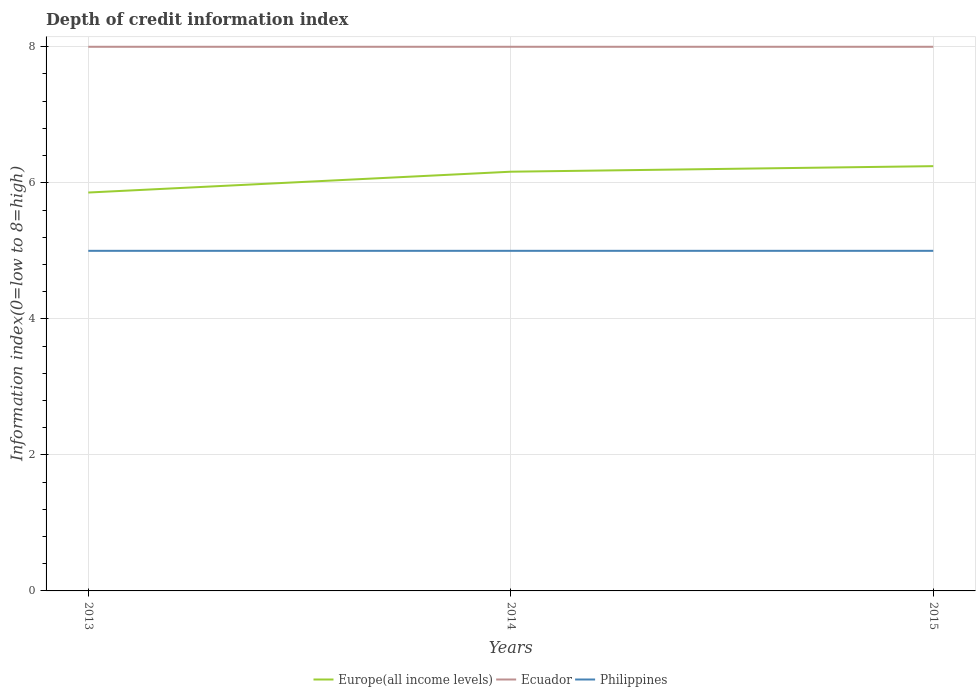How many different coloured lines are there?
Keep it short and to the point. 3. Does the line corresponding to Ecuador intersect with the line corresponding to Philippines?
Offer a terse response. No. Is the number of lines equal to the number of legend labels?
Offer a very short reply. Yes. Across all years, what is the maximum information index in Europe(all income levels)?
Offer a terse response. 5.86. In which year was the information index in Philippines maximum?
Keep it short and to the point. 2013. What is the total information index in Philippines in the graph?
Offer a terse response. 0. How many lines are there?
Give a very brief answer. 3. How many years are there in the graph?
Offer a very short reply. 3. Are the values on the major ticks of Y-axis written in scientific E-notation?
Provide a short and direct response. No. Does the graph contain grids?
Ensure brevity in your answer.  Yes. Where does the legend appear in the graph?
Ensure brevity in your answer.  Bottom center. How are the legend labels stacked?
Keep it short and to the point. Horizontal. What is the title of the graph?
Your response must be concise. Depth of credit information index. What is the label or title of the Y-axis?
Provide a succinct answer. Information index(0=low to 8=high). What is the Information index(0=low to 8=high) in Europe(all income levels) in 2013?
Offer a very short reply. 5.86. What is the Information index(0=low to 8=high) in Europe(all income levels) in 2014?
Provide a succinct answer. 6.16. What is the Information index(0=low to 8=high) of Ecuador in 2014?
Offer a terse response. 8. What is the Information index(0=low to 8=high) in Europe(all income levels) in 2015?
Keep it short and to the point. 6.24. What is the Information index(0=low to 8=high) of Ecuador in 2015?
Your answer should be compact. 8. Across all years, what is the maximum Information index(0=low to 8=high) of Europe(all income levels)?
Provide a succinct answer. 6.24. Across all years, what is the maximum Information index(0=low to 8=high) of Philippines?
Make the answer very short. 5. Across all years, what is the minimum Information index(0=low to 8=high) of Europe(all income levels)?
Provide a succinct answer. 5.86. Across all years, what is the minimum Information index(0=low to 8=high) of Ecuador?
Keep it short and to the point. 8. What is the total Information index(0=low to 8=high) of Europe(all income levels) in the graph?
Keep it short and to the point. 18.27. What is the total Information index(0=low to 8=high) in Ecuador in the graph?
Your response must be concise. 24. What is the difference between the Information index(0=low to 8=high) in Europe(all income levels) in 2013 and that in 2014?
Offer a terse response. -0.31. What is the difference between the Information index(0=low to 8=high) in Philippines in 2013 and that in 2014?
Give a very brief answer. 0. What is the difference between the Information index(0=low to 8=high) in Europe(all income levels) in 2013 and that in 2015?
Ensure brevity in your answer.  -0.39. What is the difference between the Information index(0=low to 8=high) in Europe(all income levels) in 2014 and that in 2015?
Offer a very short reply. -0.08. What is the difference between the Information index(0=low to 8=high) of Europe(all income levels) in 2013 and the Information index(0=low to 8=high) of Ecuador in 2014?
Offer a very short reply. -2.14. What is the difference between the Information index(0=low to 8=high) in Ecuador in 2013 and the Information index(0=low to 8=high) in Philippines in 2014?
Ensure brevity in your answer.  3. What is the difference between the Information index(0=low to 8=high) in Europe(all income levels) in 2013 and the Information index(0=low to 8=high) in Ecuador in 2015?
Your answer should be very brief. -2.14. What is the difference between the Information index(0=low to 8=high) in Europe(all income levels) in 2013 and the Information index(0=low to 8=high) in Philippines in 2015?
Your answer should be very brief. 0.86. What is the difference between the Information index(0=low to 8=high) of Europe(all income levels) in 2014 and the Information index(0=low to 8=high) of Ecuador in 2015?
Ensure brevity in your answer.  -1.84. What is the difference between the Information index(0=low to 8=high) of Europe(all income levels) in 2014 and the Information index(0=low to 8=high) of Philippines in 2015?
Provide a succinct answer. 1.16. What is the difference between the Information index(0=low to 8=high) in Ecuador in 2014 and the Information index(0=low to 8=high) in Philippines in 2015?
Keep it short and to the point. 3. What is the average Information index(0=low to 8=high) in Europe(all income levels) per year?
Provide a succinct answer. 6.09. In the year 2013, what is the difference between the Information index(0=low to 8=high) of Europe(all income levels) and Information index(0=low to 8=high) of Ecuador?
Offer a very short reply. -2.14. In the year 2013, what is the difference between the Information index(0=low to 8=high) of Europe(all income levels) and Information index(0=low to 8=high) of Philippines?
Make the answer very short. 0.86. In the year 2014, what is the difference between the Information index(0=low to 8=high) in Europe(all income levels) and Information index(0=low to 8=high) in Ecuador?
Provide a short and direct response. -1.84. In the year 2014, what is the difference between the Information index(0=low to 8=high) of Europe(all income levels) and Information index(0=low to 8=high) of Philippines?
Ensure brevity in your answer.  1.16. In the year 2014, what is the difference between the Information index(0=low to 8=high) of Ecuador and Information index(0=low to 8=high) of Philippines?
Offer a terse response. 3. In the year 2015, what is the difference between the Information index(0=low to 8=high) in Europe(all income levels) and Information index(0=low to 8=high) in Ecuador?
Your answer should be compact. -1.76. In the year 2015, what is the difference between the Information index(0=low to 8=high) in Europe(all income levels) and Information index(0=low to 8=high) in Philippines?
Your answer should be very brief. 1.24. What is the ratio of the Information index(0=low to 8=high) in Europe(all income levels) in 2013 to that in 2014?
Keep it short and to the point. 0.95. What is the ratio of the Information index(0=low to 8=high) in Europe(all income levels) in 2013 to that in 2015?
Make the answer very short. 0.94. What is the ratio of the Information index(0=low to 8=high) in Europe(all income levels) in 2014 to that in 2015?
Provide a short and direct response. 0.99. What is the difference between the highest and the second highest Information index(0=low to 8=high) of Europe(all income levels)?
Provide a short and direct response. 0.08. What is the difference between the highest and the second highest Information index(0=low to 8=high) of Ecuador?
Keep it short and to the point. 0. What is the difference between the highest and the lowest Information index(0=low to 8=high) in Europe(all income levels)?
Make the answer very short. 0.39. What is the difference between the highest and the lowest Information index(0=low to 8=high) in Philippines?
Your answer should be very brief. 0. 